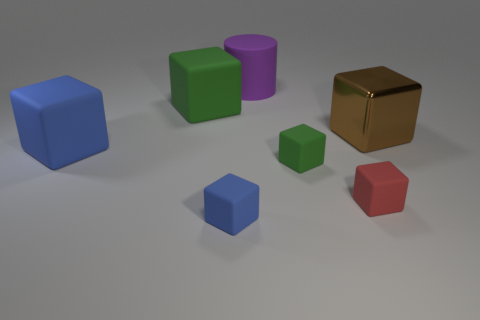Subtract all rubber cubes. How many cubes are left? 1 Subtract 3 blocks. How many blocks are left? 3 Subtract all purple cylinders. Subtract all big brown metal things. How many objects are left? 5 Add 4 small red matte blocks. How many small red matte blocks are left? 5 Add 3 tiny metallic things. How many tiny metallic things exist? 3 Add 2 big green rubber things. How many objects exist? 9 Subtract all blue cubes. How many cubes are left? 4 Subtract 0 gray cubes. How many objects are left? 7 Subtract all cylinders. How many objects are left? 6 Subtract all cyan blocks. Subtract all gray cylinders. How many blocks are left? 6 